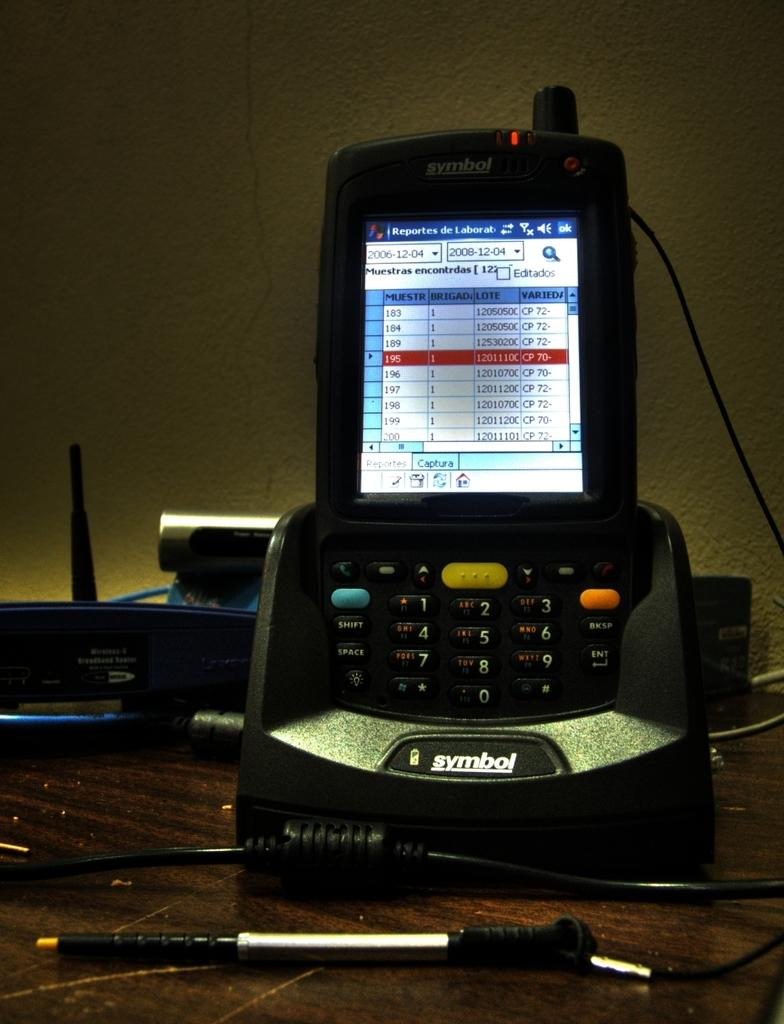Provide a one-sentence caption for the provided image. The numbers 1 through 9 are displayed on buttons on a cell phone. 